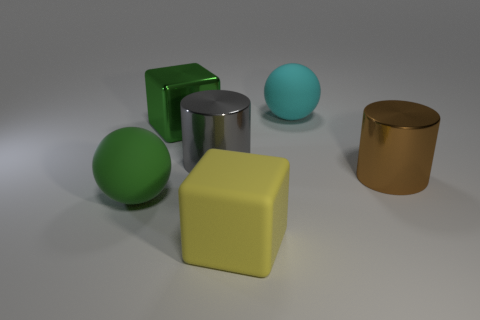Which objects in this image are most likely the heaviest and lightest based on their appearance, and why? Based on their appearance, the shiny metallic cylinder may be perceived as the heaviest due to its material and density typically associated with metal. In contrast, the blue sphere might be considered the lightest, possibly being a hollow plastic or rubber ball, judging by its uniform and matte surface. 